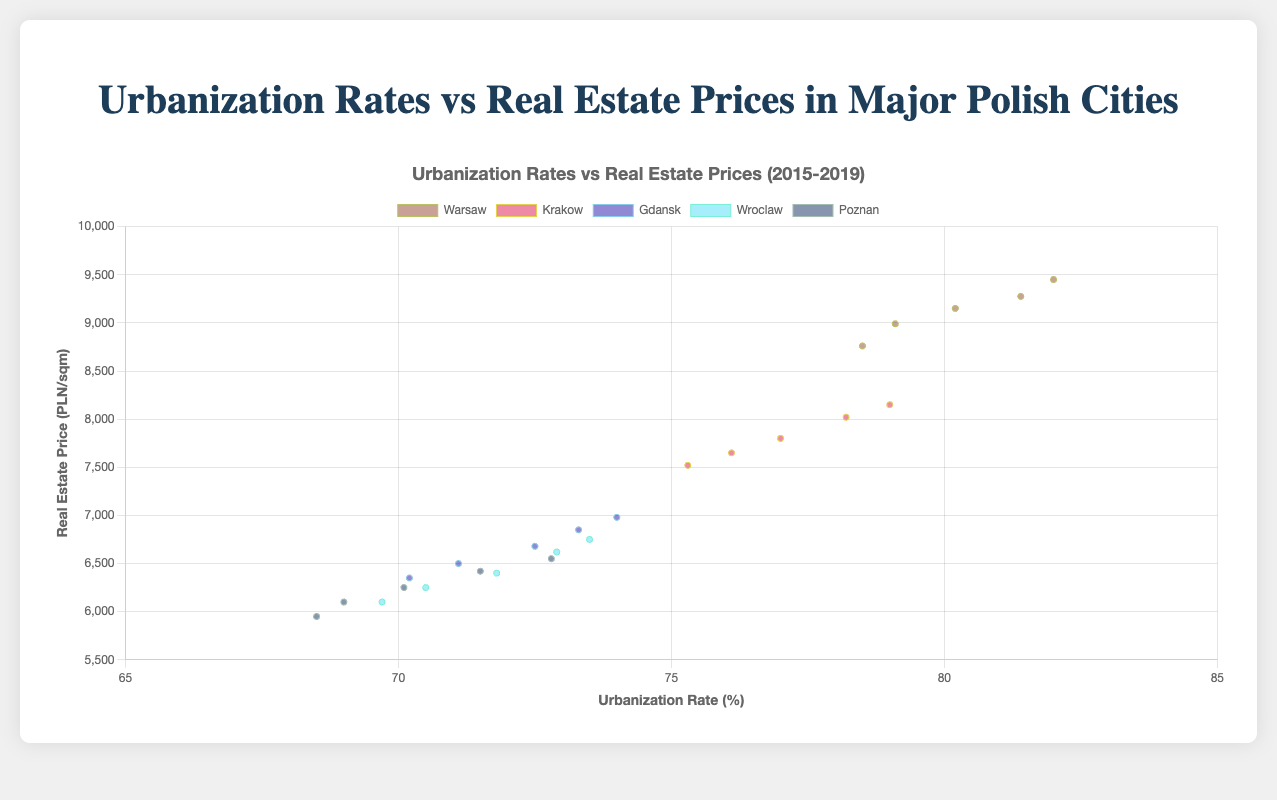What is the general trend of urbanization rates in Warsaw from 2015 to 2019? Observing the data points for Warsaw, the urbanization rate consistently increased each year from 78.5% in 2015 to 82.0% in 2019.
Answer: Increasing Which city had the highest real estate price per sqm in 2019? By checking the highest points in the vertical axis for 2019, Warsaw had the highest real estate price per sqm at 9450 PLN/sqm.
Answer: Warsaw Compare the urbanization rate change in Gdansk and Wroclaw from 2015 to 2019. Gdansk's urbanization rate increased from 70.2% in 2015 to 74.0% in 2019, a rise of 3.8 percentage points. Wroclaw's rate rose from 69.7% to 73.5%, a rise of 3.8 percentage points as well. Both cities had the same change in urbanization rate, 3.8 percentage points.
Answer: Equal Which city had the lowest real estate price per sqm in 2015? Referring to the lowest point on the vertical axis for 2015, Poznan had the lowest real estate price per sqm at 5950 PLN/sqm.
Answer: Poznan Between Krakow and Wroclaw, which city showed a steeper increase in real estate prices from 2015 to 2019? Krakow's real estate price increased from 7520 PLN/sqm in 2015 to 8150 PLN/sqm in 2019, an increase of 630 PLN/sqm. Wroclaw's prices increased from 6100 PLN/sqm to 6750 PLN/sqm, an increase of 650 PLN/sqm. Wroclaw showed a slightly steeper increase.
Answer: Wroclaw What is the average real estate price per sqm in Warsaw across the years 2015 to 2019? Sum the real estate prices for each year in Warsaw: 8760 + 8990 + 9150 + 9275 + 9450 = 45625. Divide by the number of years, 45625 / 5 = 9125 PLN/sqm.
Answer: 9125 PLN/sqm Is there a year where the urbanization rate in any city decreased from the previous year? Observing the trend lines for all cities, there are no decreases; the urbanization rates increased each year for all cities.
Answer: No For the year 2017, which city has the closest real estate price per sqm to 7500 PLN/sqm? Checking 2017 values, real estate prices are: Warsaw (9150), Krakow (7800), Gdansk (6680), Wroclaw (6400), Poznan (6250). The closest value to 7500 is Krakow at 7800 PLN/sqm.
Answer: Krakow What is the order of cities based on their urbanization rates in 2019, from highest to lowest? In 2019, checking the urbanization rates: Warsaw (82.0), Krakow (79.0), Gdansk (74.0), Wroclaw (73.5), Poznan (72.8). The order from highest to lowest is Warsaw, Krakow, Gdansk, Wroclaw, Poznan.
Answer: Warsaw, Krakow, Gdansk, Wroclaw, Poznan 